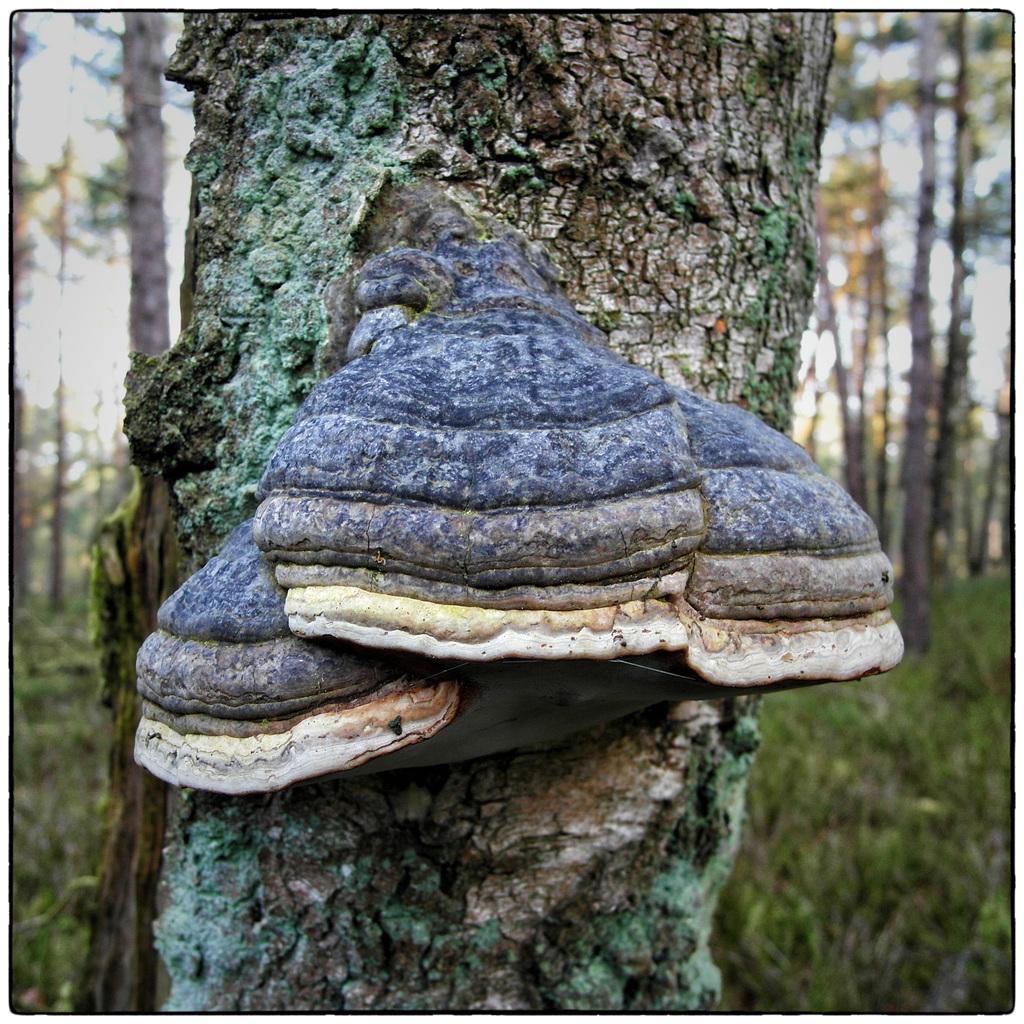In one or two sentences, can you explain what this image depicts? In the image we can see some trees. 